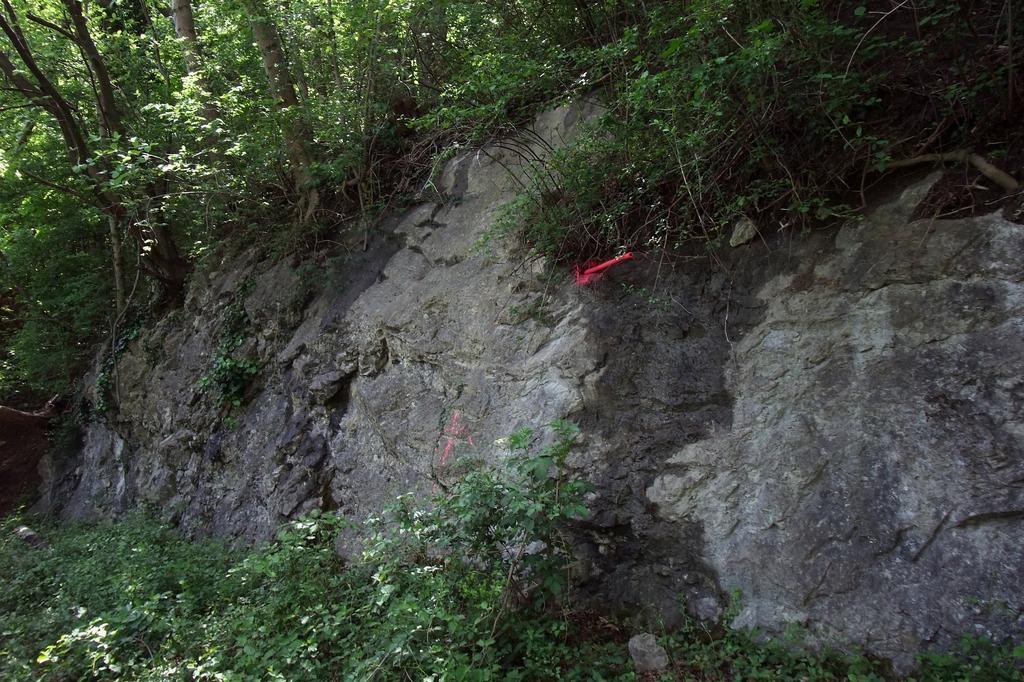Could you give a brief overview of what you see in this image? In this picture we can see a rock, plants and trees. On the rock there is a red object. 